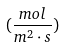Convert formula to latex. <formula><loc_0><loc_0><loc_500><loc_500>( \frac { m o l } { m ^ { 2 } \cdot s } )</formula> 